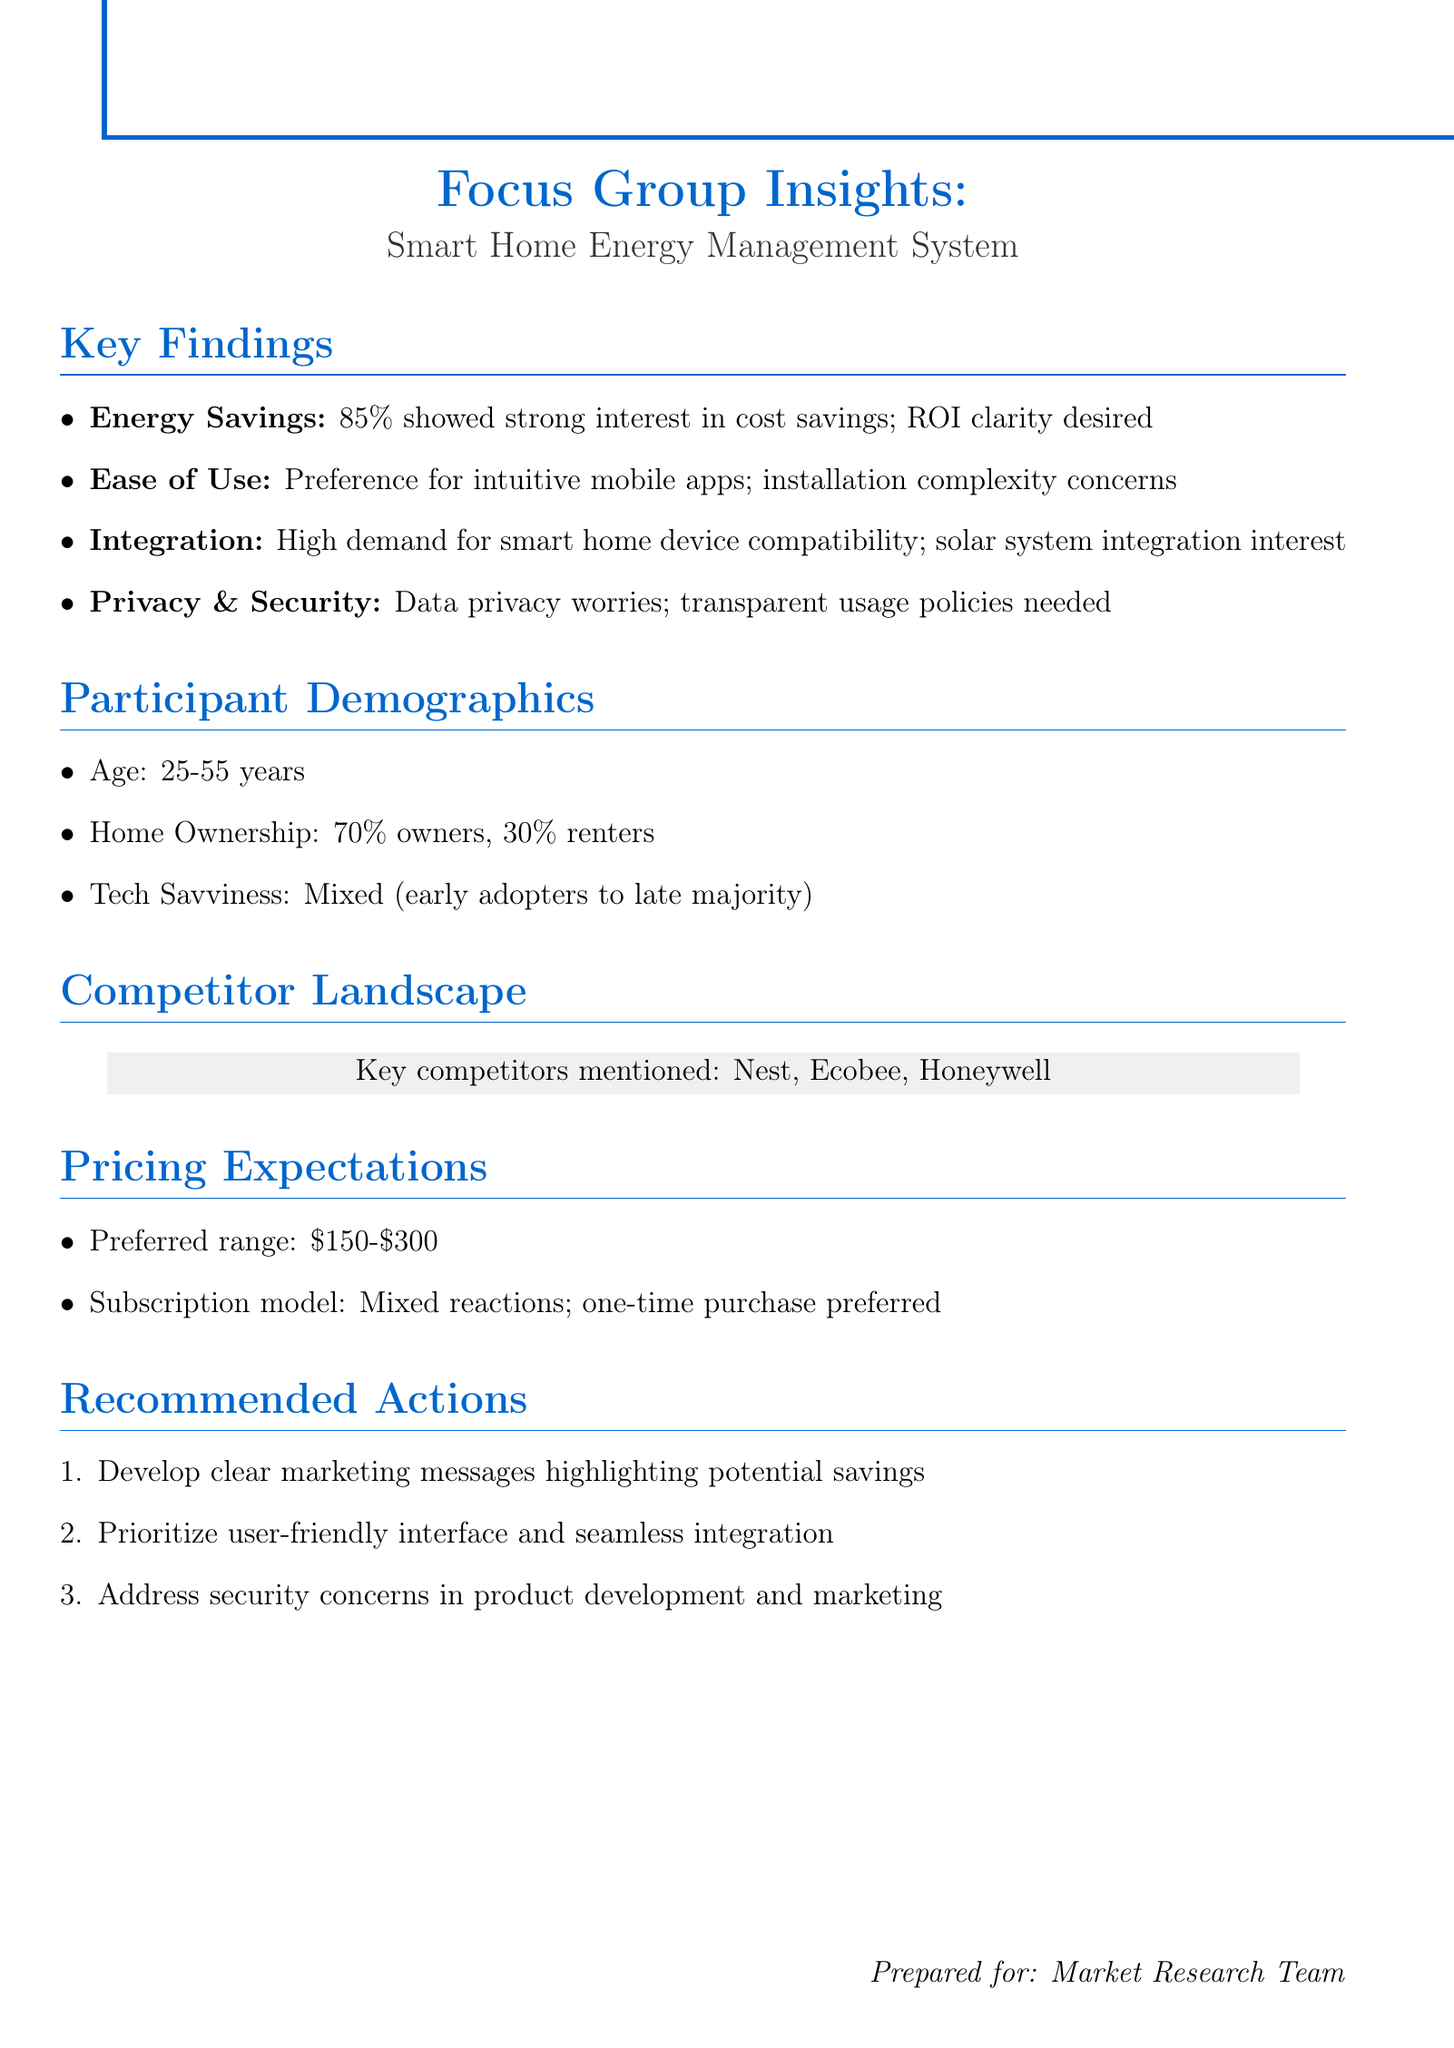What is the preferred pricing range for the product? The preferred pricing range is specified in the document under pricing expectations.
Answer: $150-$300 How many participants were homeowners? The document provides demographic information that includes the percentage of homeowners among participants.
Answer: 70% What percentage of participants expressed strong interest in energy cost savings? This information is provided under the key findings related to energy savings.
Answer: 85% What was mentioned as a key competitor in the market? The document lists competitors in the competitor landscape section, identifying notable brands.
Answer: Nest What theme addresses concerns about installation complexity? The theme corresponds to user feedback noted in the key findings, specifically mentioning ease of use.
Answer: Ease of Use What type of product integration is desired among participants? The insights regarding integration highlight specific existing technologies that participants are interested in connecting with.
Answer: Smart home devices What is a recommended action to address consumer concerns? The document lists recommended actions based on participant feedback to improve product perception.
Answer: Address security concerns What is the tech savviness level of the participants? This information is summed up in the participant demographics section, describing the technology experience level.
Answer: Mixed, from early adopters to late majority 